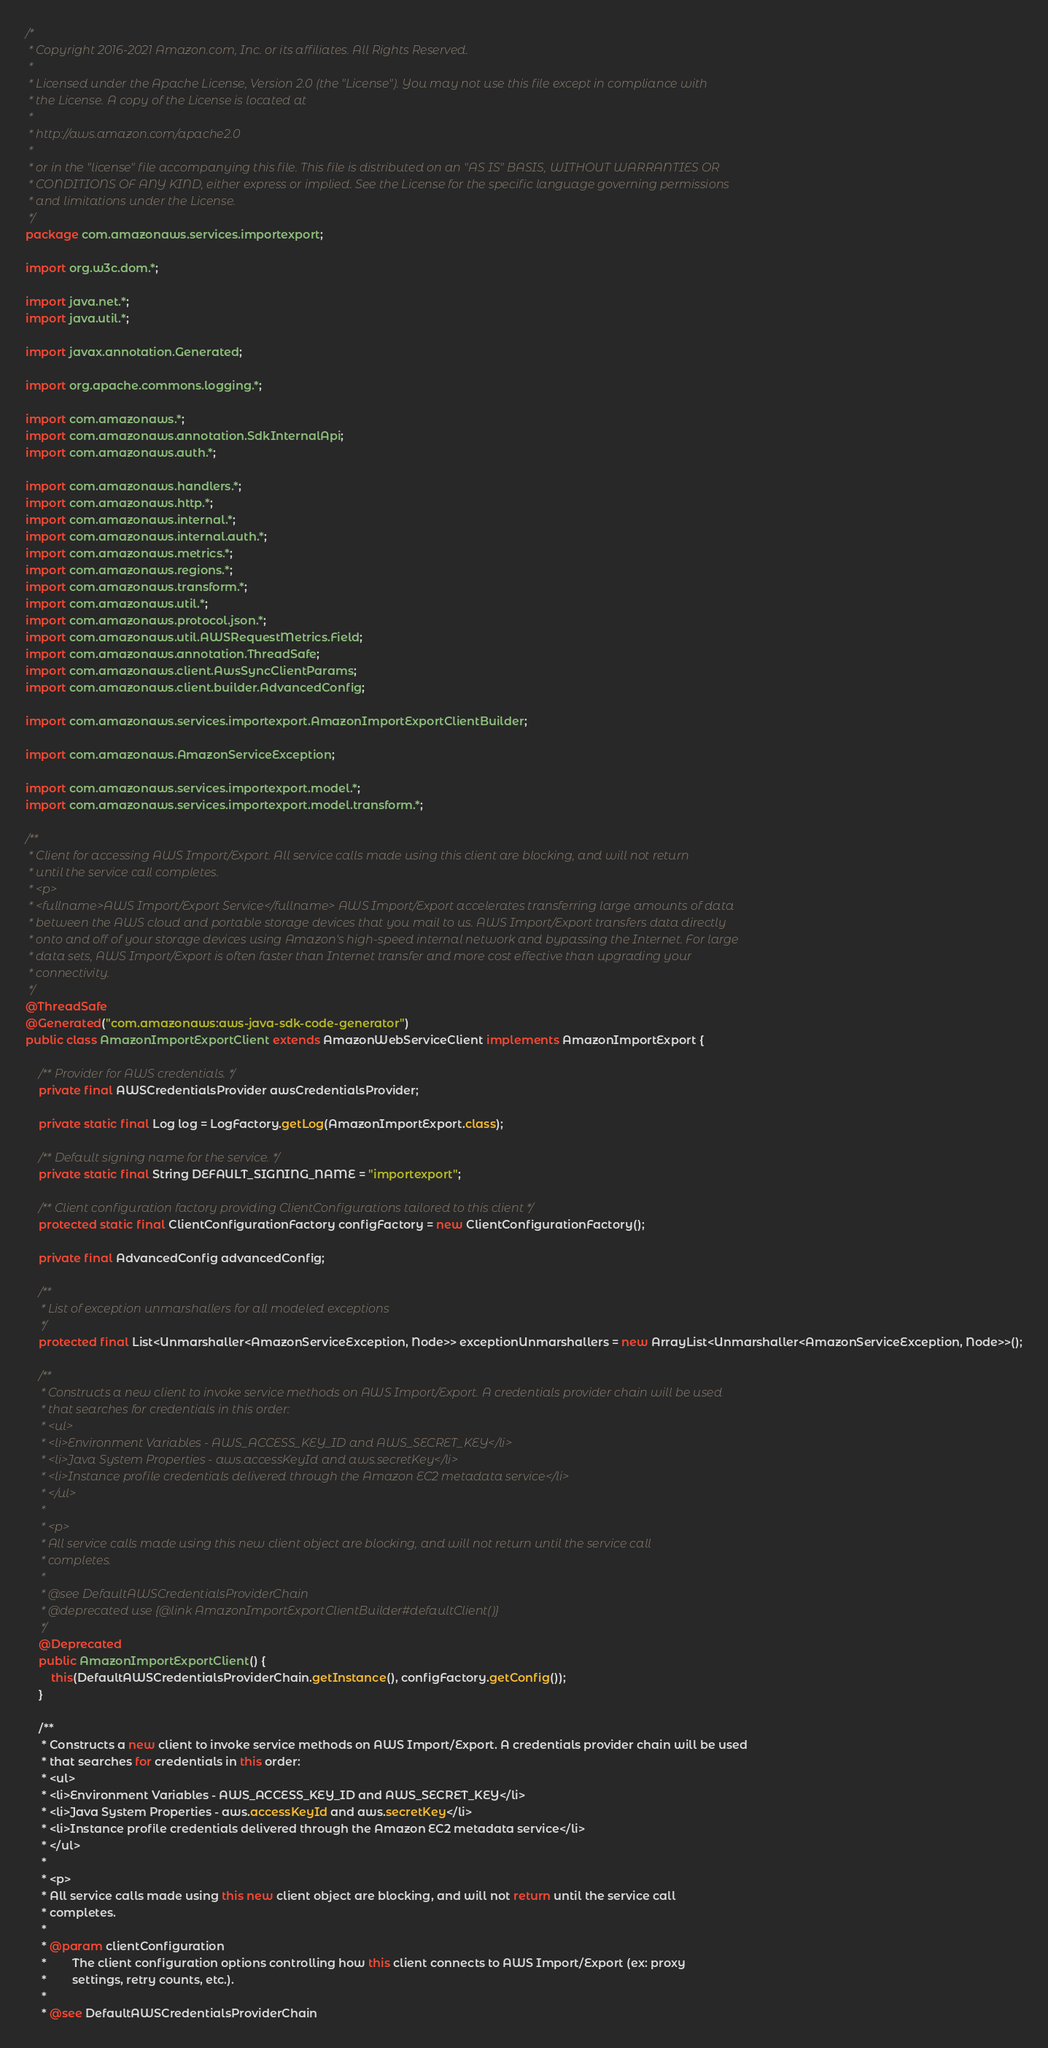Convert code to text. <code><loc_0><loc_0><loc_500><loc_500><_Java_>/*
 * Copyright 2016-2021 Amazon.com, Inc. or its affiliates. All Rights Reserved.
 * 
 * Licensed under the Apache License, Version 2.0 (the "License"). You may not use this file except in compliance with
 * the License. A copy of the License is located at
 * 
 * http://aws.amazon.com/apache2.0
 * 
 * or in the "license" file accompanying this file. This file is distributed on an "AS IS" BASIS, WITHOUT WARRANTIES OR
 * CONDITIONS OF ANY KIND, either express or implied. See the License for the specific language governing permissions
 * and limitations under the License.
 */
package com.amazonaws.services.importexport;

import org.w3c.dom.*;

import java.net.*;
import java.util.*;

import javax.annotation.Generated;

import org.apache.commons.logging.*;

import com.amazonaws.*;
import com.amazonaws.annotation.SdkInternalApi;
import com.amazonaws.auth.*;

import com.amazonaws.handlers.*;
import com.amazonaws.http.*;
import com.amazonaws.internal.*;
import com.amazonaws.internal.auth.*;
import com.amazonaws.metrics.*;
import com.amazonaws.regions.*;
import com.amazonaws.transform.*;
import com.amazonaws.util.*;
import com.amazonaws.protocol.json.*;
import com.amazonaws.util.AWSRequestMetrics.Field;
import com.amazonaws.annotation.ThreadSafe;
import com.amazonaws.client.AwsSyncClientParams;
import com.amazonaws.client.builder.AdvancedConfig;

import com.amazonaws.services.importexport.AmazonImportExportClientBuilder;

import com.amazonaws.AmazonServiceException;

import com.amazonaws.services.importexport.model.*;
import com.amazonaws.services.importexport.model.transform.*;

/**
 * Client for accessing AWS Import/Export. All service calls made using this client are blocking, and will not return
 * until the service call completes.
 * <p>
 * <fullname>AWS Import/Export Service</fullname> AWS Import/Export accelerates transferring large amounts of data
 * between the AWS cloud and portable storage devices that you mail to us. AWS Import/Export transfers data directly
 * onto and off of your storage devices using Amazon's high-speed internal network and bypassing the Internet. For large
 * data sets, AWS Import/Export is often faster than Internet transfer and more cost effective than upgrading your
 * connectivity.
 */
@ThreadSafe
@Generated("com.amazonaws:aws-java-sdk-code-generator")
public class AmazonImportExportClient extends AmazonWebServiceClient implements AmazonImportExport {

    /** Provider for AWS credentials. */
    private final AWSCredentialsProvider awsCredentialsProvider;

    private static final Log log = LogFactory.getLog(AmazonImportExport.class);

    /** Default signing name for the service. */
    private static final String DEFAULT_SIGNING_NAME = "importexport";

    /** Client configuration factory providing ClientConfigurations tailored to this client */
    protected static final ClientConfigurationFactory configFactory = new ClientConfigurationFactory();

    private final AdvancedConfig advancedConfig;

    /**
     * List of exception unmarshallers for all modeled exceptions
     */
    protected final List<Unmarshaller<AmazonServiceException, Node>> exceptionUnmarshallers = new ArrayList<Unmarshaller<AmazonServiceException, Node>>();

    /**
     * Constructs a new client to invoke service methods on AWS Import/Export. A credentials provider chain will be used
     * that searches for credentials in this order:
     * <ul>
     * <li>Environment Variables - AWS_ACCESS_KEY_ID and AWS_SECRET_KEY</li>
     * <li>Java System Properties - aws.accessKeyId and aws.secretKey</li>
     * <li>Instance profile credentials delivered through the Amazon EC2 metadata service</li>
     * </ul>
     *
     * <p>
     * All service calls made using this new client object are blocking, and will not return until the service call
     * completes.
     *
     * @see DefaultAWSCredentialsProviderChain
     * @deprecated use {@link AmazonImportExportClientBuilder#defaultClient()}
     */
    @Deprecated
    public AmazonImportExportClient() {
        this(DefaultAWSCredentialsProviderChain.getInstance(), configFactory.getConfig());
    }

    /**
     * Constructs a new client to invoke service methods on AWS Import/Export. A credentials provider chain will be used
     * that searches for credentials in this order:
     * <ul>
     * <li>Environment Variables - AWS_ACCESS_KEY_ID and AWS_SECRET_KEY</li>
     * <li>Java System Properties - aws.accessKeyId and aws.secretKey</li>
     * <li>Instance profile credentials delivered through the Amazon EC2 metadata service</li>
     * </ul>
     *
     * <p>
     * All service calls made using this new client object are blocking, and will not return until the service call
     * completes.
     *
     * @param clientConfiguration
     *        The client configuration options controlling how this client connects to AWS Import/Export (ex: proxy
     *        settings, retry counts, etc.).
     *
     * @see DefaultAWSCredentialsProviderChain</code> 